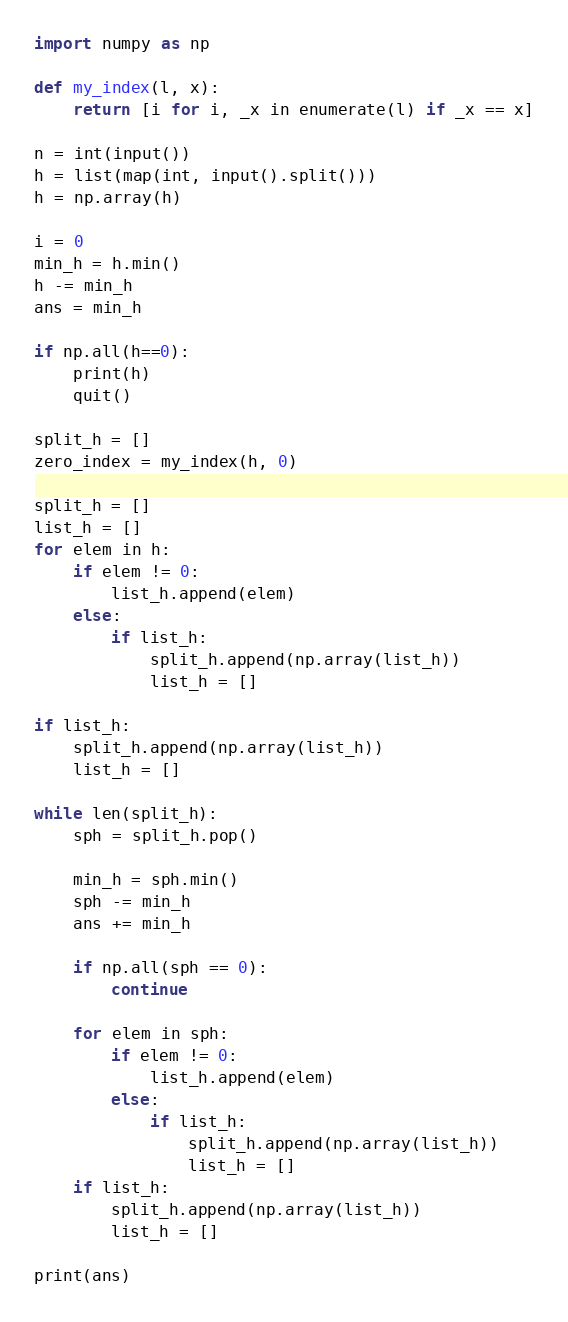<code> <loc_0><loc_0><loc_500><loc_500><_Python_>import numpy as np

def my_index(l, x):
    return [i for i, _x in enumerate(l) if _x == x]

n = int(input())
h = list(map(int, input().split()))
h = np.array(h)

i = 0
min_h = h.min()
h -= min_h
ans = min_h

if np.all(h==0):
    print(h)
    quit()

split_h = []
zero_index = my_index(h, 0)

split_h = []
list_h = []
for elem in h:
    if elem != 0:
        list_h.append(elem)
    else:
        if list_h:
            split_h.append(np.array(list_h))
            list_h = []

if list_h:
    split_h.append(np.array(list_h))
    list_h = []

while len(split_h):
    sph = split_h.pop()

    min_h = sph.min()
    sph -= min_h
    ans += min_h

    if np.all(sph == 0):
        continue

    for elem in sph:
        if elem != 0:
            list_h.append(elem)
        else:
            if list_h:
                split_h.append(np.array(list_h))
                list_h = []
    if list_h:
        split_h.append(np.array(list_h))
        list_h = []

print(ans)
</code> 